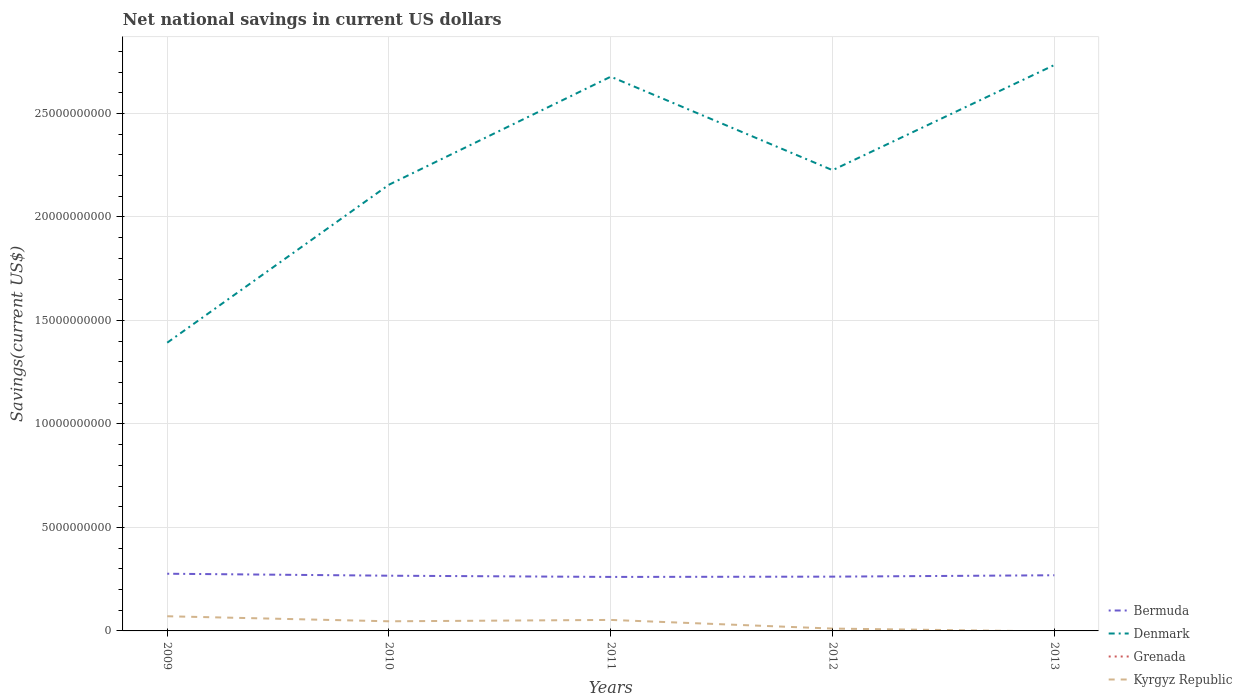How many different coloured lines are there?
Provide a short and direct response. 3. Is the number of lines equal to the number of legend labels?
Offer a very short reply. No. Across all years, what is the maximum net national savings in Kyrgyz Republic?
Your answer should be very brief. 0. What is the total net national savings in Kyrgyz Republic in the graph?
Your answer should be very brief. 1.77e+08. What is the difference between the highest and the second highest net national savings in Kyrgyz Republic?
Your answer should be compact. 7.09e+08. What is the difference between the highest and the lowest net national savings in Kyrgyz Republic?
Ensure brevity in your answer.  3. How many lines are there?
Keep it short and to the point. 3. Does the graph contain any zero values?
Give a very brief answer. Yes. What is the title of the graph?
Your response must be concise. Net national savings in current US dollars. Does "Grenada" appear as one of the legend labels in the graph?
Keep it short and to the point. Yes. What is the label or title of the X-axis?
Make the answer very short. Years. What is the label or title of the Y-axis?
Your answer should be very brief. Savings(current US$). What is the Savings(current US$) of Bermuda in 2009?
Your response must be concise. 2.76e+09. What is the Savings(current US$) of Denmark in 2009?
Ensure brevity in your answer.  1.39e+1. What is the Savings(current US$) in Kyrgyz Republic in 2009?
Provide a succinct answer. 7.09e+08. What is the Savings(current US$) in Bermuda in 2010?
Make the answer very short. 2.67e+09. What is the Savings(current US$) in Denmark in 2010?
Offer a very short reply. 2.16e+1. What is the Savings(current US$) in Grenada in 2010?
Your response must be concise. 0. What is the Savings(current US$) of Kyrgyz Republic in 2010?
Offer a very short reply. 4.65e+08. What is the Savings(current US$) of Bermuda in 2011?
Make the answer very short. 2.61e+09. What is the Savings(current US$) of Denmark in 2011?
Give a very brief answer. 2.68e+1. What is the Savings(current US$) of Grenada in 2011?
Provide a short and direct response. 0. What is the Savings(current US$) in Kyrgyz Republic in 2011?
Keep it short and to the point. 5.31e+08. What is the Savings(current US$) of Bermuda in 2012?
Provide a succinct answer. 2.62e+09. What is the Savings(current US$) in Denmark in 2012?
Make the answer very short. 2.23e+1. What is the Savings(current US$) of Grenada in 2012?
Your answer should be very brief. 0. What is the Savings(current US$) in Kyrgyz Republic in 2012?
Your answer should be compact. 1.13e+08. What is the Savings(current US$) of Bermuda in 2013?
Offer a terse response. 2.69e+09. What is the Savings(current US$) of Denmark in 2013?
Give a very brief answer. 2.73e+1. What is the Savings(current US$) in Kyrgyz Republic in 2013?
Provide a short and direct response. 0. Across all years, what is the maximum Savings(current US$) in Bermuda?
Offer a terse response. 2.76e+09. Across all years, what is the maximum Savings(current US$) of Denmark?
Your answer should be very brief. 2.73e+1. Across all years, what is the maximum Savings(current US$) of Kyrgyz Republic?
Your response must be concise. 7.09e+08. Across all years, what is the minimum Savings(current US$) in Bermuda?
Ensure brevity in your answer.  2.61e+09. Across all years, what is the minimum Savings(current US$) in Denmark?
Provide a succinct answer. 1.39e+1. Across all years, what is the minimum Savings(current US$) in Kyrgyz Republic?
Offer a very short reply. 0. What is the total Savings(current US$) in Bermuda in the graph?
Make the answer very short. 1.34e+1. What is the total Savings(current US$) in Denmark in the graph?
Keep it short and to the point. 1.12e+11. What is the total Savings(current US$) in Grenada in the graph?
Give a very brief answer. 0. What is the total Savings(current US$) of Kyrgyz Republic in the graph?
Your answer should be very brief. 1.82e+09. What is the difference between the Savings(current US$) of Bermuda in 2009 and that in 2010?
Your answer should be very brief. 9.50e+07. What is the difference between the Savings(current US$) in Denmark in 2009 and that in 2010?
Offer a terse response. -7.63e+09. What is the difference between the Savings(current US$) of Kyrgyz Republic in 2009 and that in 2010?
Ensure brevity in your answer.  2.44e+08. What is the difference between the Savings(current US$) in Bermuda in 2009 and that in 2011?
Give a very brief answer. 1.54e+08. What is the difference between the Savings(current US$) in Denmark in 2009 and that in 2011?
Keep it short and to the point. -1.29e+1. What is the difference between the Savings(current US$) of Kyrgyz Republic in 2009 and that in 2011?
Your answer should be very brief. 1.77e+08. What is the difference between the Savings(current US$) of Bermuda in 2009 and that in 2012?
Provide a succinct answer. 1.41e+08. What is the difference between the Savings(current US$) in Denmark in 2009 and that in 2012?
Keep it short and to the point. -8.33e+09. What is the difference between the Savings(current US$) in Kyrgyz Republic in 2009 and that in 2012?
Provide a short and direct response. 5.95e+08. What is the difference between the Savings(current US$) in Bermuda in 2009 and that in 2013?
Give a very brief answer. 7.37e+07. What is the difference between the Savings(current US$) of Denmark in 2009 and that in 2013?
Your answer should be very brief. -1.34e+1. What is the difference between the Savings(current US$) of Bermuda in 2010 and that in 2011?
Offer a very short reply. 5.94e+07. What is the difference between the Savings(current US$) of Denmark in 2010 and that in 2011?
Offer a very short reply. -5.22e+09. What is the difference between the Savings(current US$) of Kyrgyz Republic in 2010 and that in 2011?
Provide a succinct answer. -6.61e+07. What is the difference between the Savings(current US$) of Bermuda in 2010 and that in 2012?
Provide a short and direct response. 4.56e+07. What is the difference between the Savings(current US$) of Denmark in 2010 and that in 2012?
Ensure brevity in your answer.  -7.01e+08. What is the difference between the Savings(current US$) in Kyrgyz Republic in 2010 and that in 2012?
Your response must be concise. 3.52e+08. What is the difference between the Savings(current US$) of Bermuda in 2010 and that in 2013?
Your answer should be compact. -2.13e+07. What is the difference between the Savings(current US$) of Denmark in 2010 and that in 2013?
Your response must be concise. -5.78e+09. What is the difference between the Savings(current US$) of Bermuda in 2011 and that in 2012?
Keep it short and to the point. -1.38e+07. What is the difference between the Savings(current US$) of Denmark in 2011 and that in 2012?
Provide a succinct answer. 4.52e+09. What is the difference between the Savings(current US$) in Kyrgyz Republic in 2011 and that in 2012?
Make the answer very short. 4.18e+08. What is the difference between the Savings(current US$) in Bermuda in 2011 and that in 2013?
Your answer should be compact. -8.06e+07. What is the difference between the Savings(current US$) of Denmark in 2011 and that in 2013?
Offer a terse response. -5.63e+08. What is the difference between the Savings(current US$) in Bermuda in 2012 and that in 2013?
Provide a succinct answer. -6.69e+07. What is the difference between the Savings(current US$) in Denmark in 2012 and that in 2013?
Provide a succinct answer. -5.08e+09. What is the difference between the Savings(current US$) in Bermuda in 2009 and the Savings(current US$) in Denmark in 2010?
Offer a very short reply. -1.88e+1. What is the difference between the Savings(current US$) in Bermuda in 2009 and the Savings(current US$) in Kyrgyz Republic in 2010?
Ensure brevity in your answer.  2.30e+09. What is the difference between the Savings(current US$) in Denmark in 2009 and the Savings(current US$) in Kyrgyz Republic in 2010?
Offer a very short reply. 1.35e+1. What is the difference between the Savings(current US$) of Bermuda in 2009 and the Savings(current US$) of Denmark in 2011?
Ensure brevity in your answer.  -2.40e+1. What is the difference between the Savings(current US$) of Bermuda in 2009 and the Savings(current US$) of Kyrgyz Republic in 2011?
Keep it short and to the point. 2.23e+09. What is the difference between the Savings(current US$) of Denmark in 2009 and the Savings(current US$) of Kyrgyz Republic in 2011?
Give a very brief answer. 1.34e+1. What is the difference between the Savings(current US$) of Bermuda in 2009 and the Savings(current US$) of Denmark in 2012?
Keep it short and to the point. -1.95e+1. What is the difference between the Savings(current US$) of Bermuda in 2009 and the Savings(current US$) of Kyrgyz Republic in 2012?
Offer a terse response. 2.65e+09. What is the difference between the Savings(current US$) of Denmark in 2009 and the Savings(current US$) of Kyrgyz Republic in 2012?
Keep it short and to the point. 1.38e+1. What is the difference between the Savings(current US$) in Bermuda in 2009 and the Savings(current US$) in Denmark in 2013?
Give a very brief answer. -2.46e+1. What is the difference between the Savings(current US$) in Bermuda in 2010 and the Savings(current US$) in Denmark in 2011?
Keep it short and to the point. -2.41e+1. What is the difference between the Savings(current US$) of Bermuda in 2010 and the Savings(current US$) of Kyrgyz Republic in 2011?
Make the answer very short. 2.14e+09. What is the difference between the Savings(current US$) in Denmark in 2010 and the Savings(current US$) in Kyrgyz Republic in 2011?
Offer a terse response. 2.10e+1. What is the difference between the Savings(current US$) of Bermuda in 2010 and the Savings(current US$) of Denmark in 2012?
Ensure brevity in your answer.  -1.96e+1. What is the difference between the Savings(current US$) in Bermuda in 2010 and the Savings(current US$) in Kyrgyz Republic in 2012?
Your response must be concise. 2.55e+09. What is the difference between the Savings(current US$) of Denmark in 2010 and the Savings(current US$) of Kyrgyz Republic in 2012?
Offer a very short reply. 2.14e+1. What is the difference between the Savings(current US$) in Bermuda in 2010 and the Savings(current US$) in Denmark in 2013?
Provide a succinct answer. -2.47e+1. What is the difference between the Savings(current US$) in Bermuda in 2011 and the Savings(current US$) in Denmark in 2012?
Your answer should be compact. -1.97e+1. What is the difference between the Savings(current US$) in Bermuda in 2011 and the Savings(current US$) in Kyrgyz Republic in 2012?
Your response must be concise. 2.50e+09. What is the difference between the Savings(current US$) in Denmark in 2011 and the Savings(current US$) in Kyrgyz Republic in 2012?
Ensure brevity in your answer.  2.67e+1. What is the difference between the Savings(current US$) in Bermuda in 2011 and the Savings(current US$) in Denmark in 2013?
Your response must be concise. -2.47e+1. What is the difference between the Savings(current US$) of Bermuda in 2012 and the Savings(current US$) of Denmark in 2013?
Offer a terse response. -2.47e+1. What is the average Savings(current US$) in Bermuda per year?
Your answer should be compact. 2.67e+09. What is the average Savings(current US$) of Denmark per year?
Your answer should be compact. 2.24e+1. What is the average Savings(current US$) in Grenada per year?
Ensure brevity in your answer.  0. What is the average Savings(current US$) of Kyrgyz Republic per year?
Give a very brief answer. 3.64e+08. In the year 2009, what is the difference between the Savings(current US$) in Bermuda and Savings(current US$) in Denmark?
Your answer should be very brief. -1.12e+1. In the year 2009, what is the difference between the Savings(current US$) in Bermuda and Savings(current US$) in Kyrgyz Republic?
Offer a very short reply. 2.05e+09. In the year 2009, what is the difference between the Savings(current US$) of Denmark and Savings(current US$) of Kyrgyz Republic?
Give a very brief answer. 1.32e+1. In the year 2010, what is the difference between the Savings(current US$) in Bermuda and Savings(current US$) in Denmark?
Your answer should be very brief. -1.89e+1. In the year 2010, what is the difference between the Savings(current US$) of Bermuda and Savings(current US$) of Kyrgyz Republic?
Your response must be concise. 2.20e+09. In the year 2010, what is the difference between the Savings(current US$) in Denmark and Savings(current US$) in Kyrgyz Republic?
Give a very brief answer. 2.11e+1. In the year 2011, what is the difference between the Savings(current US$) in Bermuda and Savings(current US$) in Denmark?
Provide a succinct answer. -2.42e+1. In the year 2011, what is the difference between the Savings(current US$) of Bermuda and Savings(current US$) of Kyrgyz Republic?
Your answer should be compact. 2.08e+09. In the year 2011, what is the difference between the Savings(current US$) of Denmark and Savings(current US$) of Kyrgyz Republic?
Your response must be concise. 2.62e+1. In the year 2012, what is the difference between the Savings(current US$) of Bermuda and Savings(current US$) of Denmark?
Make the answer very short. -1.96e+1. In the year 2012, what is the difference between the Savings(current US$) in Bermuda and Savings(current US$) in Kyrgyz Republic?
Give a very brief answer. 2.51e+09. In the year 2012, what is the difference between the Savings(current US$) in Denmark and Savings(current US$) in Kyrgyz Republic?
Provide a short and direct response. 2.21e+1. In the year 2013, what is the difference between the Savings(current US$) in Bermuda and Savings(current US$) in Denmark?
Give a very brief answer. -2.47e+1. What is the ratio of the Savings(current US$) in Bermuda in 2009 to that in 2010?
Your answer should be very brief. 1.04. What is the ratio of the Savings(current US$) of Denmark in 2009 to that in 2010?
Provide a succinct answer. 0.65. What is the ratio of the Savings(current US$) in Kyrgyz Republic in 2009 to that in 2010?
Your response must be concise. 1.52. What is the ratio of the Savings(current US$) of Bermuda in 2009 to that in 2011?
Offer a terse response. 1.06. What is the ratio of the Savings(current US$) of Denmark in 2009 to that in 2011?
Your answer should be compact. 0.52. What is the ratio of the Savings(current US$) in Kyrgyz Republic in 2009 to that in 2011?
Give a very brief answer. 1.33. What is the ratio of the Savings(current US$) of Bermuda in 2009 to that in 2012?
Make the answer very short. 1.05. What is the ratio of the Savings(current US$) of Denmark in 2009 to that in 2012?
Keep it short and to the point. 0.63. What is the ratio of the Savings(current US$) in Kyrgyz Republic in 2009 to that in 2012?
Your answer should be very brief. 6.25. What is the ratio of the Savings(current US$) in Bermuda in 2009 to that in 2013?
Your response must be concise. 1.03. What is the ratio of the Savings(current US$) of Denmark in 2009 to that in 2013?
Provide a short and direct response. 0.51. What is the ratio of the Savings(current US$) of Bermuda in 2010 to that in 2011?
Your answer should be very brief. 1.02. What is the ratio of the Savings(current US$) of Denmark in 2010 to that in 2011?
Give a very brief answer. 0.81. What is the ratio of the Savings(current US$) of Kyrgyz Republic in 2010 to that in 2011?
Keep it short and to the point. 0.88. What is the ratio of the Savings(current US$) in Bermuda in 2010 to that in 2012?
Your answer should be compact. 1.02. What is the ratio of the Savings(current US$) of Denmark in 2010 to that in 2012?
Offer a terse response. 0.97. What is the ratio of the Savings(current US$) of Kyrgyz Republic in 2010 to that in 2012?
Keep it short and to the point. 4.11. What is the ratio of the Savings(current US$) of Bermuda in 2010 to that in 2013?
Make the answer very short. 0.99. What is the ratio of the Savings(current US$) in Denmark in 2010 to that in 2013?
Give a very brief answer. 0.79. What is the ratio of the Savings(current US$) in Bermuda in 2011 to that in 2012?
Offer a very short reply. 0.99. What is the ratio of the Savings(current US$) in Denmark in 2011 to that in 2012?
Your answer should be very brief. 1.2. What is the ratio of the Savings(current US$) in Kyrgyz Republic in 2011 to that in 2012?
Your response must be concise. 4.69. What is the ratio of the Savings(current US$) in Bermuda in 2011 to that in 2013?
Provide a succinct answer. 0.97. What is the ratio of the Savings(current US$) in Denmark in 2011 to that in 2013?
Ensure brevity in your answer.  0.98. What is the ratio of the Savings(current US$) of Bermuda in 2012 to that in 2013?
Give a very brief answer. 0.98. What is the ratio of the Savings(current US$) in Denmark in 2012 to that in 2013?
Provide a succinct answer. 0.81. What is the difference between the highest and the second highest Savings(current US$) in Bermuda?
Ensure brevity in your answer.  7.37e+07. What is the difference between the highest and the second highest Savings(current US$) of Denmark?
Ensure brevity in your answer.  5.63e+08. What is the difference between the highest and the second highest Savings(current US$) in Kyrgyz Republic?
Keep it short and to the point. 1.77e+08. What is the difference between the highest and the lowest Savings(current US$) in Bermuda?
Provide a succinct answer. 1.54e+08. What is the difference between the highest and the lowest Savings(current US$) in Denmark?
Offer a terse response. 1.34e+1. What is the difference between the highest and the lowest Savings(current US$) in Kyrgyz Republic?
Give a very brief answer. 7.09e+08. 